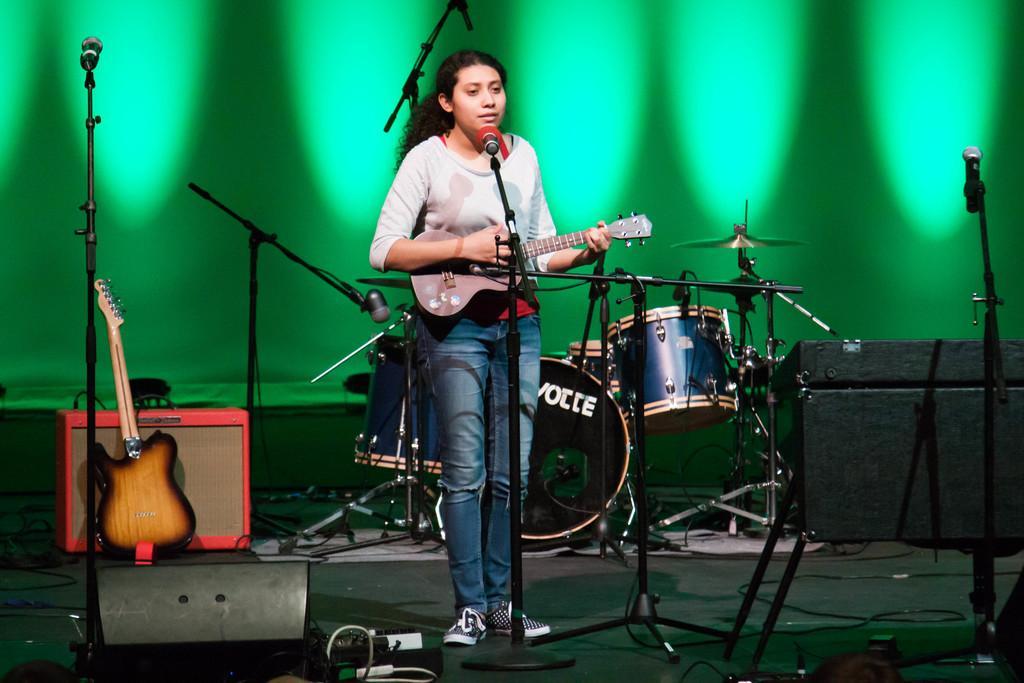Can you describe this image briefly? Here is the woman standing and singing a song. She is playing guitar. These are the drums with hi-hat instrument. These are the mics attached to their mic stands. I can see another guitar placed here. This looks like a wooden box. Background is green is color. 